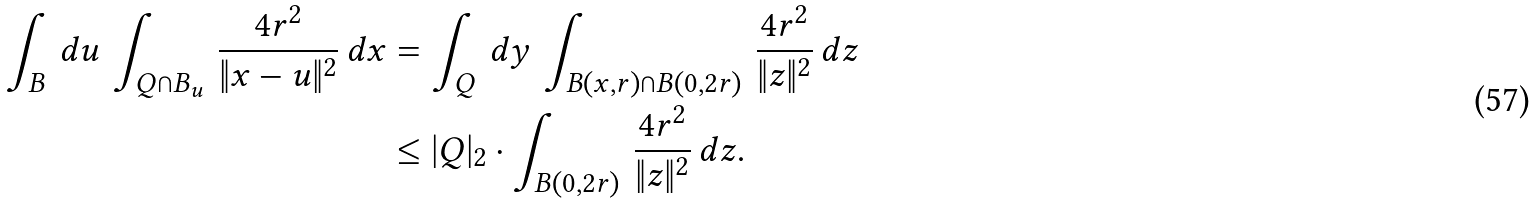<formula> <loc_0><loc_0><loc_500><loc_500>\int _ { B } \, d u \, \int _ { Q \cap B _ { u } } \, \frac { 4 r ^ { 2 } } { \| x - u \| ^ { 2 } } \, d x & = \int _ { Q } \, d y \, \int _ { B ( x , r ) \cap B ( 0 , 2 r ) } \, \frac { 4 r ^ { 2 } } { \| z \| ^ { 2 } } \, d z \\ & \leq | Q | _ { 2 } \cdot \int _ { B ( 0 , 2 r ) } \, \frac { 4 r ^ { 2 } } { \| z \| ^ { 2 } } \, d z .</formula> 